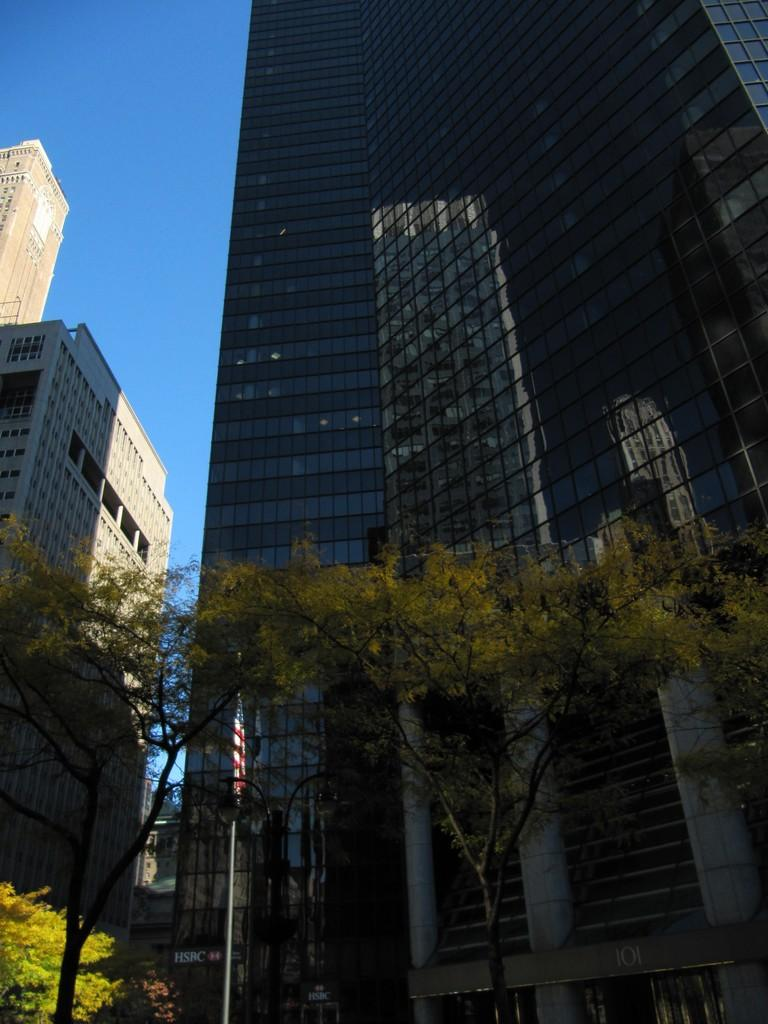What type of structures can be seen in the image? There are buildings in the image. What is located in front of the buildings? There are trees and a flag in front of the buildings. What can be seen in the background of the image? There is a sky visible in the background of the image. How many boys are playing with scissors in the image? There are no boys or scissors present in the image. 